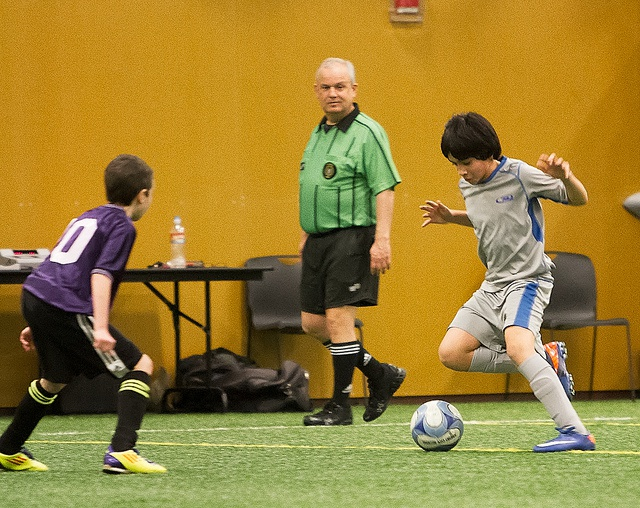Describe the objects in this image and their specific colors. I can see people in orange, darkgray, lightgray, black, and tan tones, people in orange, black, green, tan, and lightgreen tones, people in orange, black, purple, and white tones, suitcase in orange, black, and gray tones, and chair in orange, gray, black, and olive tones in this image. 